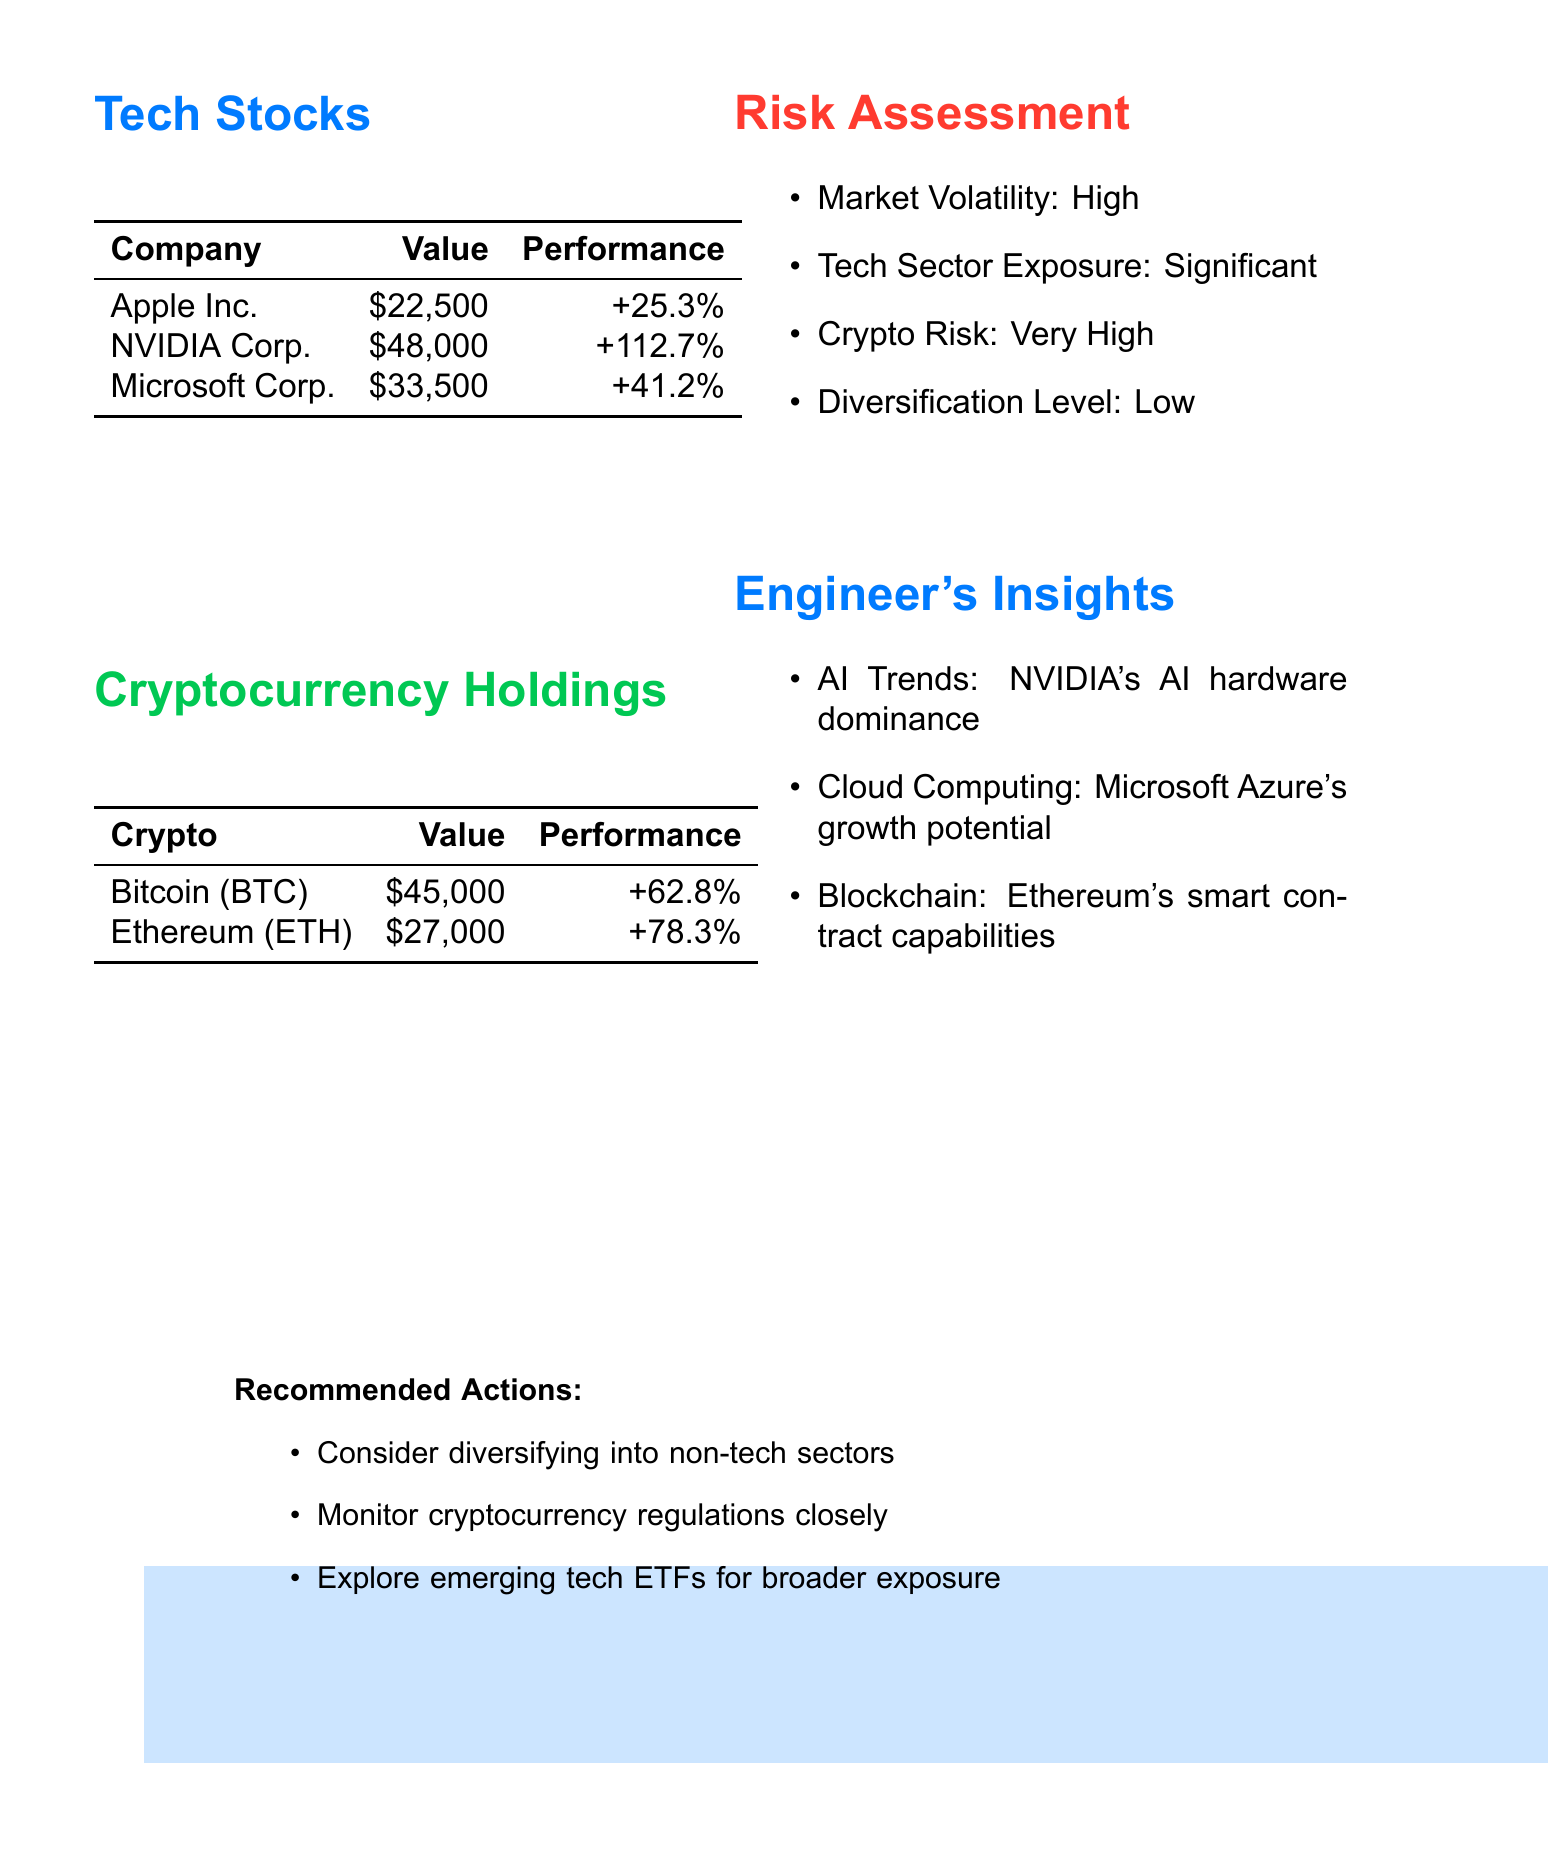what is the total value of the portfolio? The total value is presented at the top of the document, indicating the overall worth of the investment portfolio.
Answer: $785,000 what is the annual return percentage? The annual return is mentioned in the portfolio summary, providing insight into the expected return on investment over a year.
Answer: 18.7% which tech stock has the highest performance? The performance metrics for each tech stock indicate NVIDIA Corporation shows the highest growth among them.
Answer: +112.7% how many shares of Microsoft are held? The document lists the number of shares for each tech stock, including Microsoft.
Answer: 100 what is the risk level of the investment portfolio? The risk level is specified in the portfolio summary, assessing the overall risk associated with the investments.
Answer: Moderate-High how much is invested in Bitcoin? Bitcoin's current value is provided in the cryptocurrency holdings section, reflecting the investment amount.
Answer: $45,000 what is the risk assessment for cryptocurrency? The document outlines specific risks associated with cryptocurrency investments, indicating the level of concern.
Answer: Very High what are recommended actions regarding the investment portfolio? The document includes a list of suggested actions based on the current portfolio assessment to improve performance or risk.
Answer: Consider diversifying into non-tech sectors how many tech stocks are listed in the document? The document lists three tech stocks under the tech stocks section, providing specific information about each.
Answer: 3 what is the diversification level of the portfolio? The document summarizes the portfolio's diversification level, which affects overall investment risk.
Answer: Low 